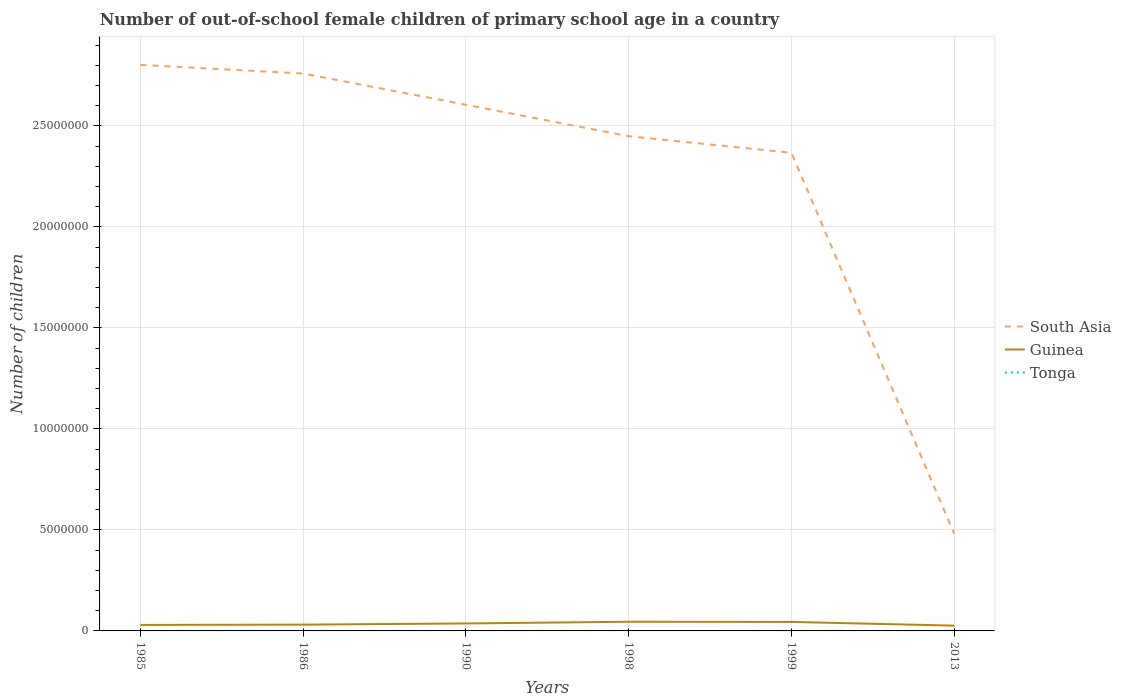How many different coloured lines are there?
Keep it short and to the point. 3. Does the line corresponding to Tonga intersect with the line corresponding to South Asia?
Ensure brevity in your answer.  No. Across all years, what is the maximum number of out-of-school female children in Tonga?
Your answer should be compact. 130. In which year was the number of out-of-school female children in Tonga maximum?
Provide a short and direct response. 1985. What is the total number of out-of-school female children in South Asia in the graph?
Your answer should be compact. 4.29e+05. What is the difference between the highest and the second highest number of out-of-school female children in Guinea?
Your answer should be compact. 1.92e+05. How many lines are there?
Offer a very short reply. 3. What is the difference between two consecutive major ticks on the Y-axis?
Keep it short and to the point. 5.00e+06. Are the values on the major ticks of Y-axis written in scientific E-notation?
Your answer should be compact. No. Does the graph contain grids?
Your answer should be compact. Yes. What is the title of the graph?
Your response must be concise. Number of out-of-school female children of primary school age in a country. What is the label or title of the X-axis?
Provide a short and direct response. Years. What is the label or title of the Y-axis?
Keep it short and to the point. Number of children. What is the Number of children in South Asia in 1985?
Ensure brevity in your answer.  2.80e+07. What is the Number of children of Guinea in 1985?
Offer a terse response. 2.96e+05. What is the Number of children in Tonga in 1985?
Your response must be concise. 130. What is the Number of children in South Asia in 1986?
Give a very brief answer. 2.76e+07. What is the Number of children of Guinea in 1986?
Your answer should be very brief. 3.11e+05. What is the Number of children in Tonga in 1986?
Ensure brevity in your answer.  243. What is the Number of children of South Asia in 1990?
Provide a succinct answer. 2.60e+07. What is the Number of children in Guinea in 1990?
Keep it short and to the point. 3.69e+05. What is the Number of children of Tonga in 1990?
Offer a very short reply. 506. What is the Number of children of South Asia in 1998?
Offer a very short reply. 2.45e+07. What is the Number of children in Guinea in 1998?
Offer a very short reply. 4.55e+05. What is the Number of children of Tonga in 1998?
Provide a succinct answer. 445. What is the Number of children of South Asia in 1999?
Ensure brevity in your answer.  2.37e+07. What is the Number of children in Guinea in 1999?
Offer a terse response. 4.45e+05. What is the Number of children in Tonga in 1999?
Offer a very short reply. 808. What is the Number of children in South Asia in 2013?
Keep it short and to the point. 4.81e+06. What is the Number of children of Guinea in 2013?
Offer a terse response. 2.62e+05. What is the Number of children in Tonga in 2013?
Your answer should be compact. 1089. Across all years, what is the maximum Number of children of South Asia?
Make the answer very short. 2.80e+07. Across all years, what is the maximum Number of children in Guinea?
Give a very brief answer. 4.55e+05. Across all years, what is the maximum Number of children in Tonga?
Keep it short and to the point. 1089. Across all years, what is the minimum Number of children in South Asia?
Make the answer very short. 4.81e+06. Across all years, what is the minimum Number of children of Guinea?
Offer a very short reply. 2.62e+05. Across all years, what is the minimum Number of children of Tonga?
Your answer should be very brief. 130. What is the total Number of children of South Asia in the graph?
Keep it short and to the point. 1.35e+08. What is the total Number of children in Guinea in the graph?
Provide a succinct answer. 2.14e+06. What is the total Number of children in Tonga in the graph?
Offer a very short reply. 3221. What is the difference between the Number of children of South Asia in 1985 and that in 1986?
Offer a terse response. 4.29e+05. What is the difference between the Number of children in Guinea in 1985 and that in 1986?
Provide a short and direct response. -1.45e+04. What is the difference between the Number of children of Tonga in 1985 and that in 1986?
Make the answer very short. -113. What is the difference between the Number of children in South Asia in 1985 and that in 1990?
Ensure brevity in your answer.  1.97e+06. What is the difference between the Number of children in Guinea in 1985 and that in 1990?
Ensure brevity in your answer.  -7.32e+04. What is the difference between the Number of children in Tonga in 1985 and that in 1990?
Make the answer very short. -376. What is the difference between the Number of children of South Asia in 1985 and that in 1998?
Ensure brevity in your answer.  3.53e+06. What is the difference between the Number of children in Guinea in 1985 and that in 1998?
Give a very brief answer. -1.58e+05. What is the difference between the Number of children of Tonga in 1985 and that in 1998?
Provide a short and direct response. -315. What is the difference between the Number of children of South Asia in 1985 and that in 1999?
Give a very brief answer. 4.35e+06. What is the difference between the Number of children of Guinea in 1985 and that in 1999?
Provide a succinct answer. -1.49e+05. What is the difference between the Number of children in Tonga in 1985 and that in 1999?
Your answer should be compact. -678. What is the difference between the Number of children of South Asia in 1985 and that in 2013?
Provide a succinct answer. 2.32e+07. What is the difference between the Number of children in Guinea in 1985 and that in 2013?
Keep it short and to the point. 3.40e+04. What is the difference between the Number of children in Tonga in 1985 and that in 2013?
Your response must be concise. -959. What is the difference between the Number of children in South Asia in 1986 and that in 1990?
Offer a very short reply. 1.55e+06. What is the difference between the Number of children in Guinea in 1986 and that in 1990?
Your answer should be compact. -5.88e+04. What is the difference between the Number of children in Tonga in 1986 and that in 1990?
Keep it short and to the point. -263. What is the difference between the Number of children of South Asia in 1986 and that in 1998?
Offer a very short reply. 3.10e+06. What is the difference between the Number of children in Guinea in 1986 and that in 1998?
Your answer should be very brief. -1.44e+05. What is the difference between the Number of children of Tonga in 1986 and that in 1998?
Offer a very short reply. -202. What is the difference between the Number of children in South Asia in 1986 and that in 1999?
Provide a succinct answer. 3.92e+06. What is the difference between the Number of children of Guinea in 1986 and that in 1999?
Give a very brief answer. -1.34e+05. What is the difference between the Number of children of Tonga in 1986 and that in 1999?
Keep it short and to the point. -565. What is the difference between the Number of children in South Asia in 1986 and that in 2013?
Make the answer very short. 2.28e+07. What is the difference between the Number of children in Guinea in 1986 and that in 2013?
Offer a terse response. 4.84e+04. What is the difference between the Number of children in Tonga in 1986 and that in 2013?
Make the answer very short. -846. What is the difference between the Number of children in South Asia in 1990 and that in 1998?
Ensure brevity in your answer.  1.56e+06. What is the difference between the Number of children of Guinea in 1990 and that in 1998?
Make the answer very short. -8.52e+04. What is the difference between the Number of children in South Asia in 1990 and that in 1999?
Offer a very short reply. 2.38e+06. What is the difference between the Number of children of Guinea in 1990 and that in 1999?
Offer a very short reply. -7.57e+04. What is the difference between the Number of children in Tonga in 1990 and that in 1999?
Your response must be concise. -302. What is the difference between the Number of children of South Asia in 1990 and that in 2013?
Keep it short and to the point. 2.12e+07. What is the difference between the Number of children of Guinea in 1990 and that in 2013?
Give a very brief answer. 1.07e+05. What is the difference between the Number of children of Tonga in 1990 and that in 2013?
Offer a terse response. -583. What is the difference between the Number of children of South Asia in 1998 and that in 1999?
Give a very brief answer. 8.18e+05. What is the difference between the Number of children in Guinea in 1998 and that in 1999?
Your answer should be compact. 9577. What is the difference between the Number of children in Tonga in 1998 and that in 1999?
Keep it short and to the point. -363. What is the difference between the Number of children of South Asia in 1998 and that in 2013?
Offer a terse response. 1.97e+07. What is the difference between the Number of children in Guinea in 1998 and that in 2013?
Keep it short and to the point. 1.92e+05. What is the difference between the Number of children in Tonga in 1998 and that in 2013?
Your answer should be compact. -644. What is the difference between the Number of children of South Asia in 1999 and that in 2013?
Offer a very short reply. 1.89e+07. What is the difference between the Number of children in Guinea in 1999 and that in 2013?
Your answer should be compact. 1.83e+05. What is the difference between the Number of children of Tonga in 1999 and that in 2013?
Provide a succinct answer. -281. What is the difference between the Number of children in South Asia in 1985 and the Number of children in Guinea in 1986?
Provide a short and direct response. 2.77e+07. What is the difference between the Number of children of South Asia in 1985 and the Number of children of Tonga in 1986?
Your answer should be very brief. 2.80e+07. What is the difference between the Number of children of Guinea in 1985 and the Number of children of Tonga in 1986?
Ensure brevity in your answer.  2.96e+05. What is the difference between the Number of children in South Asia in 1985 and the Number of children in Guinea in 1990?
Provide a short and direct response. 2.76e+07. What is the difference between the Number of children of South Asia in 1985 and the Number of children of Tonga in 1990?
Your response must be concise. 2.80e+07. What is the difference between the Number of children in Guinea in 1985 and the Number of children in Tonga in 1990?
Your answer should be very brief. 2.96e+05. What is the difference between the Number of children in South Asia in 1985 and the Number of children in Guinea in 1998?
Provide a succinct answer. 2.76e+07. What is the difference between the Number of children in South Asia in 1985 and the Number of children in Tonga in 1998?
Provide a short and direct response. 2.80e+07. What is the difference between the Number of children of Guinea in 1985 and the Number of children of Tonga in 1998?
Provide a succinct answer. 2.96e+05. What is the difference between the Number of children of South Asia in 1985 and the Number of children of Guinea in 1999?
Ensure brevity in your answer.  2.76e+07. What is the difference between the Number of children in South Asia in 1985 and the Number of children in Tonga in 1999?
Offer a very short reply. 2.80e+07. What is the difference between the Number of children in Guinea in 1985 and the Number of children in Tonga in 1999?
Your answer should be compact. 2.95e+05. What is the difference between the Number of children of South Asia in 1985 and the Number of children of Guinea in 2013?
Make the answer very short. 2.78e+07. What is the difference between the Number of children of South Asia in 1985 and the Number of children of Tonga in 2013?
Your response must be concise. 2.80e+07. What is the difference between the Number of children of Guinea in 1985 and the Number of children of Tonga in 2013?
Your answer should be compact. 2.95e+05. What is the difference between the Number of children of South Asia in 1986 and the Number of children of Guinea in 1990?
Keep it short and to the point. 2.72e+07. What is the difference between the Number of children in South Asia in 1986 and the Number of children in Tonga in 1990?
Offer a very short reply. 2.76e+07. What is the difference between the Number of children of Guinea in 1986 and the Number of children of Tonga in 1990?
Ensure brevity in your answer.  3.10e+05. What is the difference between the Number of children in South Asia in 1986 and the Number of children in Guinea in 1998?
Make the answer very short. 2.71e+07. What is the difference between the Number of children of South Asia in 1986 and the Number of children of Tonga in 1998?
Provide a short and direct response. 2.76e+07. What is the difference between the Number of children of Guinea in 1986 and the Number of children of Tonga in 1998?
Offer a very short reply. 3.10e+05. What is the difference between the Number of children in South Asia in 1986 and the Number of children in Guinea in 1999?
Your answer should be very brief. 2.71e+07. What is the difference between the Number of children of South Asia in 1986 and the Number of children of Tonga in 1999?
Keep it short and to the point. 2.76e+07. What is the difference between the Number of children in Guinea in 1986 and the Number of children in Tonga in 1999?
Offer a terse response. 3.10e+05. What is the difference between the Number of children of South Asia in 1986 and the Number of children of Guinea in 2013?
Your answer should be compact. 2.73e+07. What is the difference between the Number of children of South Asia in 1986 and the Number of children of Tonga in 2013?
Make the answer very short. 2.76e+07. What is the difference between the Number of children of Guinea in 1986 and the Number of children of Tonga in 2013?
Give a very brief answer. 3.10e+05. What is the difference between the Number of children in South Asia in 1990 and the Number of children in Guinea in 1998?
Give a very brief answer. 2.56e+07. What is the difference between the Number of children in South Asia in 1990 and the Number of children in Tonga in 1998?
Your answer should be compact. 2.60e+07. What is the difference between the Number of children in Guinea in 1990 and the Number of children in Tonga in 1998?
Make the answer very short. 3.69e+05. What is the difference between the Number of children of South Asia in 1990 and the Number of children of Guinea in 1999?
Ensure brevity in your answer.  2.56e+07. What is the difference between the Number of children in South Asia in 1990 and the Number of children in Tonga in 1999?
Give a very brief answer. 2.60e+07. What is the difference between the Number of children in Guinea in 1990 and the Number of children in Tonga in 1999?
Your response must be concise. 3.69e+05. What is the difference between the Number of children in South Asia in 1990 and the Number of children in Guinea in 2013?
Give a very brief answer. 2.58e+07. What is the difference between the Number of children of South Asia in 1990 and the Number of children of Tonga in 2013?
Provide a short and direct response. 2.60e+07. What is the difference between the Number of children of Guinea in 1990 and the Number of children of Tonga in 2013?
Keep it short and to the point. 3.68e+05. What is the difference between the Number of children of South Asia in 1998 and the Number of children of Guinea in 1999?
Offer a very short reply. 2.40e+07. What is the difference between the Number of children in South Asia in 1998 and the Number of children in Tonga in 1999?
Your answer should be very brief. 2.45e+07. What is the difference between the Number of children of Guinea in 1998 and the Number of children of Tonga in 1999?
Give a very brief answer. 4.54e+05. What is the difference between the Number of children of South Asia in 1998 and the Number of children of Guinea in 2013?
Your answer should be very brief. 2.42e+07. What is the difference between the Number of children of South Asia in 1998 and the Number of children of Tonga in 2013?
Your response must be concise. 2.45e+07. What is the difference between the Number of children of Guinea in 1998 and the Number of children of Tonga in 2013?
Provide a short and direct response. 4.54e+05. What is the difference between the Number of children of South Asia in 1999 and the Number of children of Guinea in 2013?
Your response must be concise. 2.34e+07. What is the difference between the Number of children of South Asia in 1999 and the Number of children of Tonga in 2013?
Provide a succinct answer. 2.37e+07. What is the difference between the Number of children in Guinea in 1999 and the Number of children in Tonga in 2013?
Your answer should be very brief. 4.44e+05. What is the average Number of children in South Asia per year?
Provide a succinct answer. 2.24e+07. What is the average Number of children of Guinea per year?
Your answer should be very brief. 3.56e+05. What is the average Number of children of Tonga per year?
Make the answer very short. 536.83. In the year 1985, what is the difference between the Number of children of South Asia and Number of children of Guinea?
Provide a succinct answer. 2.77e+07. In the year 1985, what is the difference between the Number of children of South Asia and Number of children of Tonga?
Your response must be concise. 2.80e+07. In the year 1985, what is the difference between the Number of children in Guinea and Number of children in Tonga?
Your answer should be compact. 2.96e+05. In the year 1986, what is the difference between the Number of children in South Asia and Number of children in Guinea?
Offer a very short reply. 2.73e+07. In the year 1986, what is the difference between the Number of children in South Asia and Number of children in Tonga?
Offer a very short reply. 2.76e+07. In the year 1986, what is the difference between the Number of children of Guinea and Number of children of Tonga?
Give a very brief answer. 3.10e+05. In the year 1990, what is the difference between the Number of children in South Asia and Number of children in Guinea?
Keep it short and to the point. 2.57e+07. In the year 1990, what is the difference between the Number of children of South Asia and Number of children of Tonga?
Give a very brief answer. 2.60e+07. In the year 1990, what is the difference between the Number of children in Guinea and Number of children in Tonga?
Offer a terse response. 3.69e+05. In the year 1998, what is the difference between the Number of children of South Asia and Number of children of Guinea?
Offer a very short reply. 2.40e+07. In the year 1998, what is the difference between the Number of children in South Asia and Number of children in Tonga?
Your answer should be compact. 2.45e+07. In the year 1998, what is the difference between the Number of children in Guinea and Number of children in Tonga?
Keep it short and to the point. 4.54e+05. In the year 1999, what is the difference between the Number of children of South Asia and Number of children of Guinea?
Your response must be concise. 2.32e+07. In the year 1999, what is the difference between the Number of children of South Asia and Number of children of Tonga?
Your response must be concise. 2.37e+07. In the year 1999, what is the difference between the Number of children of Guinea and Number of children of Tonga?
Offer a terse response. 4.44e+05. In the year 2013, what is the difference between the Number of children in South Asia and Number of children in Guinea?
Keep it short and to the point. 4.55e+06. In the year 2013, what is the difference between the Number of children of South Asia and Number of children of Tonga?
Your response must be concise. 4.81e+06. In the year 2013, what is the difference between the Number of children in Guinea and Number of children in Tonga?
Provide a short and direct response. 2.61e+05. What is the ratio of the Number of children in South Asia in 1985 to that in 1986?
Offer a terse response. 1.02. What is the ratio of the Number of children in Guinea in 1985 to that in 1986?
Provide a succinct answer. 0.95. What is the ratio of the Number of children of Tonga in 1985 to that in 1986?
Make the answer very short. 0.54. What is the ratio of the Number of children of South Asia in 1985 to that in 1990?
Your response must be concise. 1.08. What is the ratio of the Number of children of Guinea in 1985 to that in 1990?
Ensure brevity in your answer.  0.8. What is the ratio of the Number of children in Tonga in 1985 to that in 1990?
Offer a very short reply. 0.26. What is the ratio of the Number of children of South Asia in 1985 to that in 1998?
Provide a succinct answer. 1.14. What is the ratio of the Number of children in Guinea in 1985 to that in 1998?
Your answer should be very brief. 0.65. What is the ratio of the Number of children in Tonga in 1985 to that in 1998?
Your response must be concise. 0.29. What is the ratio of the Number of children in South Asia in 1985 to that in 1999?
Provide a succinct answer. 1.18. What is the ratio of the Number of children of Guinea in 1985 to that in 1999?
Your response must be concise. 0.67. What is the ratio of the Number of children in Tonga in 1985 to that in 1999?
Your answer should be very brief. 0.16. What is the ratio of the Number of children of South Asia in 1985 to that in 2013?
Your answer should be compact. 5.82. What is the ratio of the Number of children in Guinea in 1985 to that in 2013?
Provide a short and direct response. 1.13. What is the ratio of the Number of children of Tonga in 1985 to that in 2013?
Make the answer very short. 0.12. What is the ratio of the Number of children in South Asia in 1986 to that in 1990?
Provide a succinct answer. 1.06. What is the ratio of the Number of children of Guinea in 1986 to that in 1990?
Your response must be concise. 0.84. What is the ratio of the Number of children in Tonga in 1986 to that in 1990?
Provide a succinct answer. 0.48. What is the ratio of the Number of children in South Asia in 1986 to that in 1998?
Give a very brief answer. 1.13. What is the ratio of the Number of children in Guinea in 1986 to that in 1998?
Your answer should be compact. 0.68. What is the ratio of the Number of children of Tonga in 1986 to that in 1998?
Provide a short and direct response. 0.55. What is the ratio of the Number of children in South Asia in 1986 to that in 1999?
Make the answer very short. 1.17. What is the ratio of the Number of children in Guinea in 1986 to that in 1999?
Provide a succinct answer. 0.7. What is the ratio of the Number of children in Tonga in 1986 to that in 1999?
Your answer should be very brief. 0.3. What is the ratio of the Number of children of South Asia in 1986 to that in 2013?
Provide a succinct answer. 5.73. What is the ratio of the Number of children in Guinea in 1986 to that in 2013?
Offer a terse response. 1.18. What is the ratio of the Number of children of Tonga in 1986 to that in 2013?
Your response must be concise. 0.22. What is the ratio of the Number of children in South Asia in 1990 to that in 1998?
Provide a succinct answer. 1.06. What is the ratio of the Number of children in Guinea in 1990 to that in 1998?
Provide a short and direct response. 0.81. What is the ratio of the Number of children of Tonga in 1990 to that in 1998?
Your answer should be very brief. 1.14. What is the ratio of the Number of children of South Asia in 1990 to that in 1999?
Provide a succinct answer. 1.1. What is the ratio of the Number of children of Guinea in 1990 to that in 1999?
Offer a terse response. 0.83. What is the ratio of the Number of children of Tonga in 1990 to that in 1999?
Ensure brevity in your answer.  0.63. What is the ratio of the Number of children of South Asia in 1990 to that in 2013?
Give a very brief answer. 5.41. What is the ratio of the Number of children in Guinea in 1990 to that in 2013?
Offer a very short reply. 1.41. What is the ratio of the Number of children of Tonga in 1990 to that in 2013?
Make the answer very short. 0.46. What is the ratio of the Number of children of South Asia in 1998 to that in 1999?
Make the answer very short. 1.03. What is the ratio of the Number of children in Guinea in 1998 to that in 1999?
Give a very brief answer. 1.02. What is the ratio of the Number of children in Tonga in 1998 to that in 1999?
Your answer should be compact. 0.55. What is the ratio of the Number of children in South Asia in 1998 to that in 2013?
Your response must be concise. 5.09. What is the ratio of the Number of children of Guinea in 1998 to that in 2013?
Your answer should be very brief. 1.73. What is the ratio of the Number of children in Tonga in 1998 to that in 2013?
Offer a very short reply. 0.41. What is the ratio of the Number of children in South Asia in 1999 to that in 2013?
Make the answer very short. 4.92. What is the ratio of the Number of children of Guinea in 1999 to that in 2013?
Your response must be concise. 1.7. What is the ratio of the Number of children in Tonga in 1999 to that in 2013?
Make the answer very short. 0.74. What is the difference between the highest and the second highest Number of children in South Asia?
Offer a terse response. 4.29e+05. What is the difference between the highest and the second highest Number of children in Guinea?
Provide a short and direct response. 9577. What is the difference between the highest and the second highest Number of children in Tonga?
Ensure brevity in your answer.  281. What is the difference between the highest and the lowest Number of children of South Asia?
Provide a short and direct response. 2.32e+07. What is the difference between the highest and the lowest Number of children in Guinea?
Offer a terse response. 1.92e+05. What is the difference between the highest and the lowest Number of children of Tonga?
Your answer should be compact. 959. 